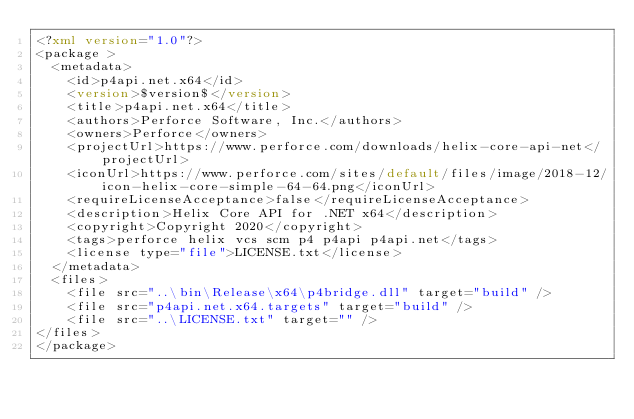<code> <loc_0><loc_0><loc_500><loc_500><_XML_><?xml version="1.0"?>
<package >
  <metadata>
    <id>p4api.net.x64</id>
    <version>$version$</version>
    <title>p4api.net.x64</title>
    <authors>Perforce Software, Inc.</authors>
    <owners>Perforce</owners>
    <projectUrl>https://www.perforce.com/downloads/helix-core-api-net</projectUrl>
    <iconUrl>https://www.perforce.com/sites/default/files/image/2018-12/icon-helix-core-simple-64-64.png</iconUrl>
    <requireLicenseAcceptance>false</requireLicenseAcceptance>
    <description>Helix Core API for .NET x64</description>
    <copyright>Copyright 2020</copyright>
    <tags>perforce helix vcs scm p4 p4api p4api.net</tags>
	<license type="file">LICENSE.txt</license>
  </metadata>
  <files>
    <file src="..\bin\Release\x64\p4bridge.dll" target="build" />
	<file src="p4api.net.x64.targets" target="build" />
	<file src="..\LICENSE.txt" target="" />	
</files>
</package></code> 